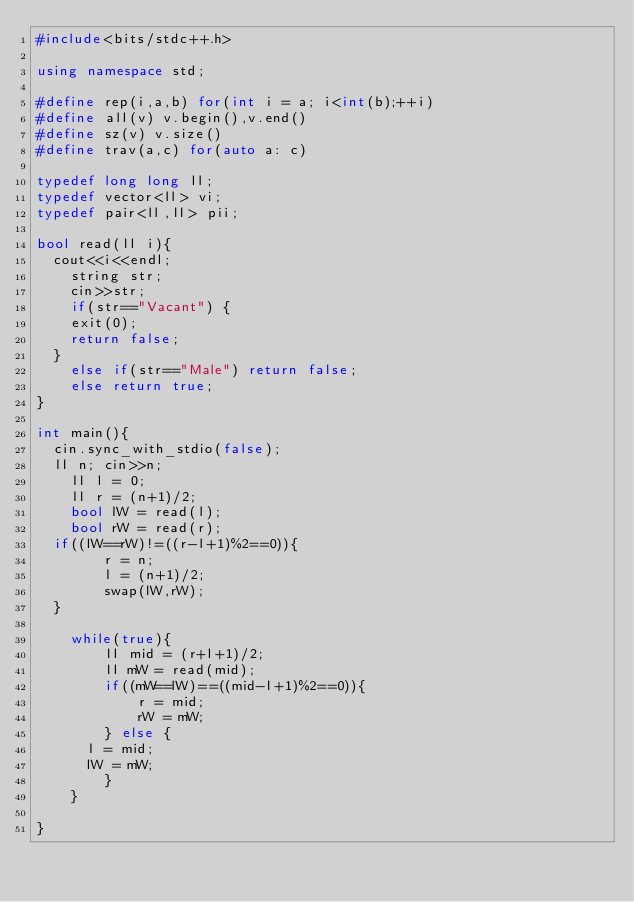<code> <loc_0><loc_0><loc_500><loc_500><_C++_>#include<bits/stdc++.h>

using namespace std;

#define rep(i,a,b) for(int i = a; i<int(b);++i)
#define all(v) v.begin(),v.end()
#define sz(v) v.size()
#define trav(a,c) for(auto a: c)

typedef long long ll;
typedef vector<ll> vi;
typedef pair<ll,ll> pii;

bool read(ll i){
	cout<<i<<endl;
    string str;
    cin>>str;
    if(str=="Vacant") {
		exit(0);
		return false;
	}
    else if(str=="Male") return false;
    else return true;
}

int main(){
	cin.sync_with_stdio(false);
	ll n; cin>>n;
    ll l = 0;
    ll r = (n+1)/2;
    bool lW = read(l);
    bool rW = read(r);
	if((lW==rW)!=((r-l+1)%2==0)){
        r = n;
        l = (n+1)/2;
        swap(lW,rW);
	}

    while(true){
        ll mid = (r+l+1)/2;
        ll mW = read(mid);
        if((mW==lW)==((mid-l+1)%2==0)){
            r = mid;
            rW = mW;
        } else {
			l = mid;
			lW = mW;
        }
    }

}
</code> 